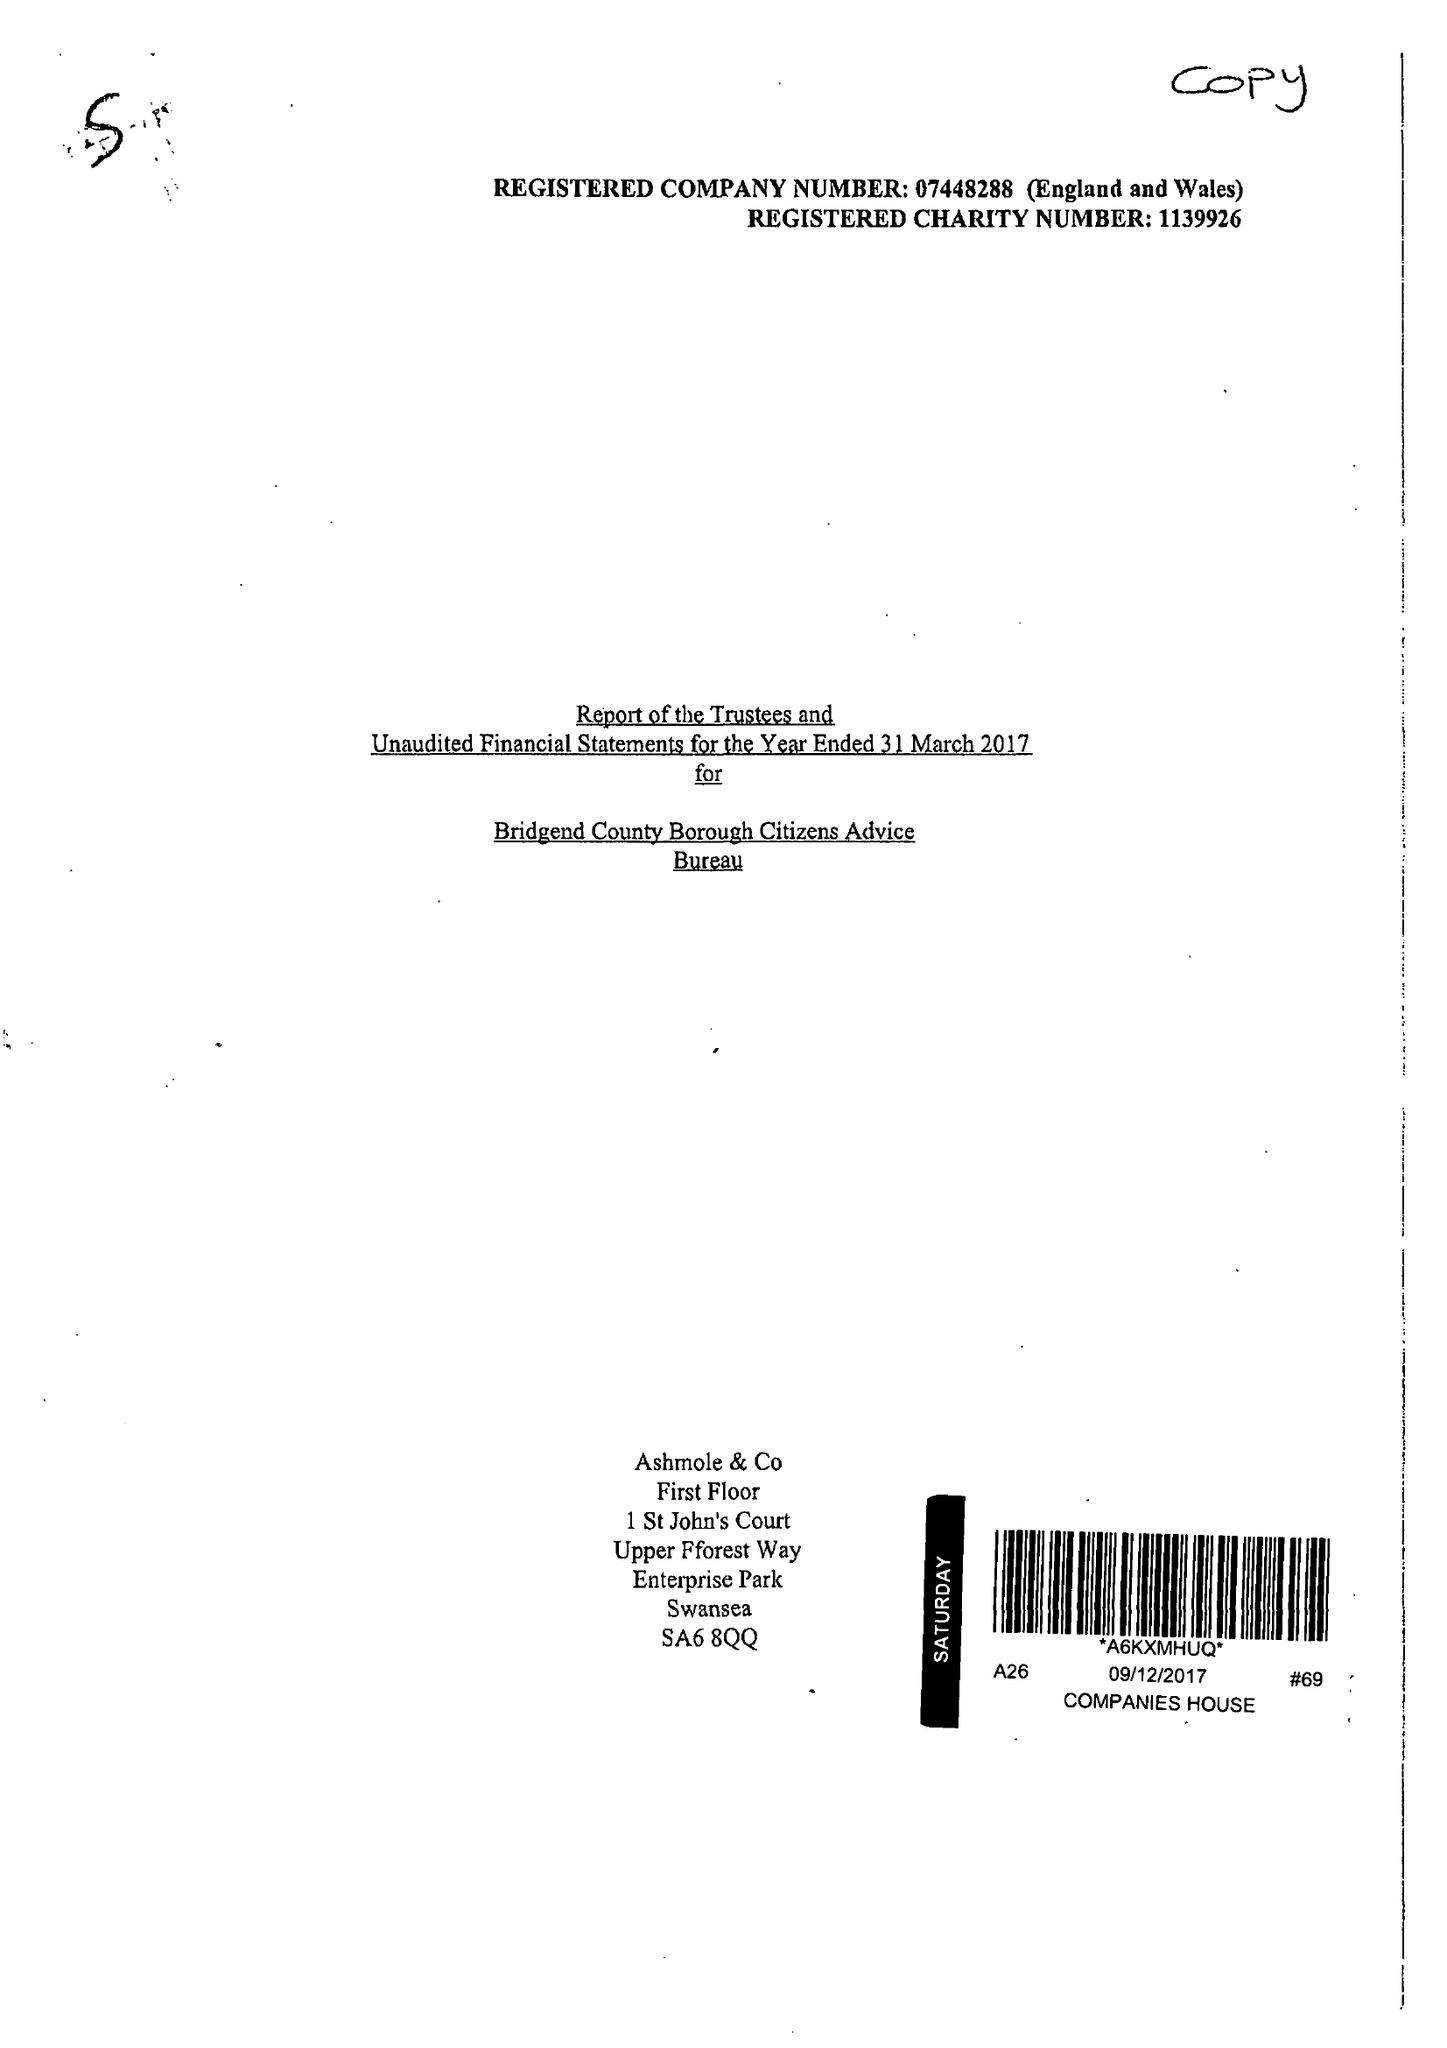What is the value for the address__street_line?
Answer the question using a single word or phrase. 26 DUNRAVEN PLACE 